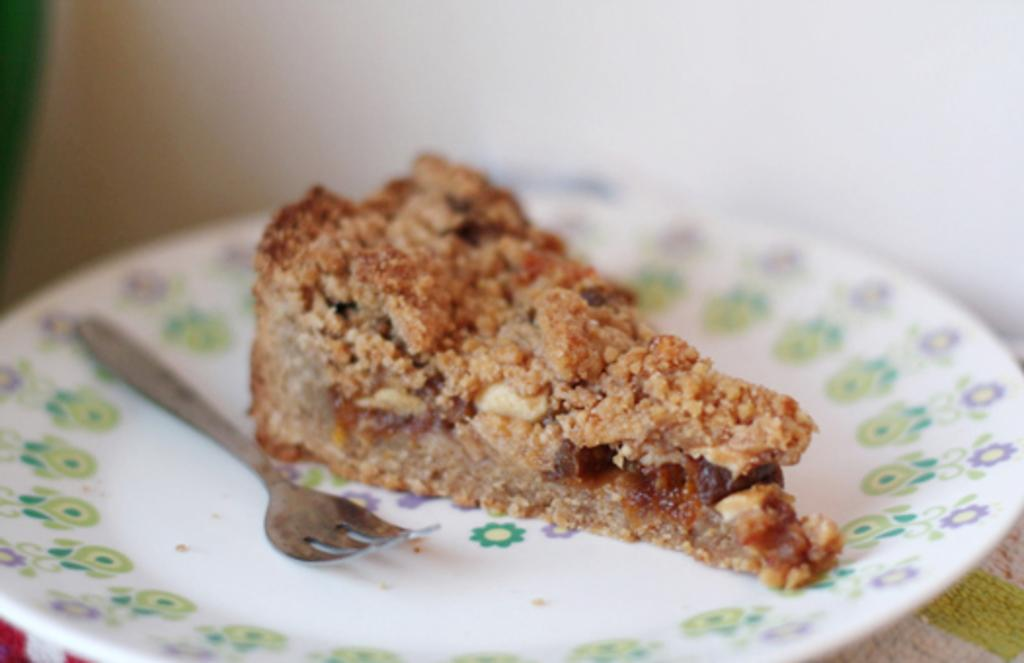What is on the plate that is visible in the image? There is a piece of cake on the plate. What utensil is placed on the plate? There is a fork on the plate. What design can be seen on the plate? The plate has designs on it. What holiday is being celebrated in the image? There is no indication of a holiday being celebrated in the image. 